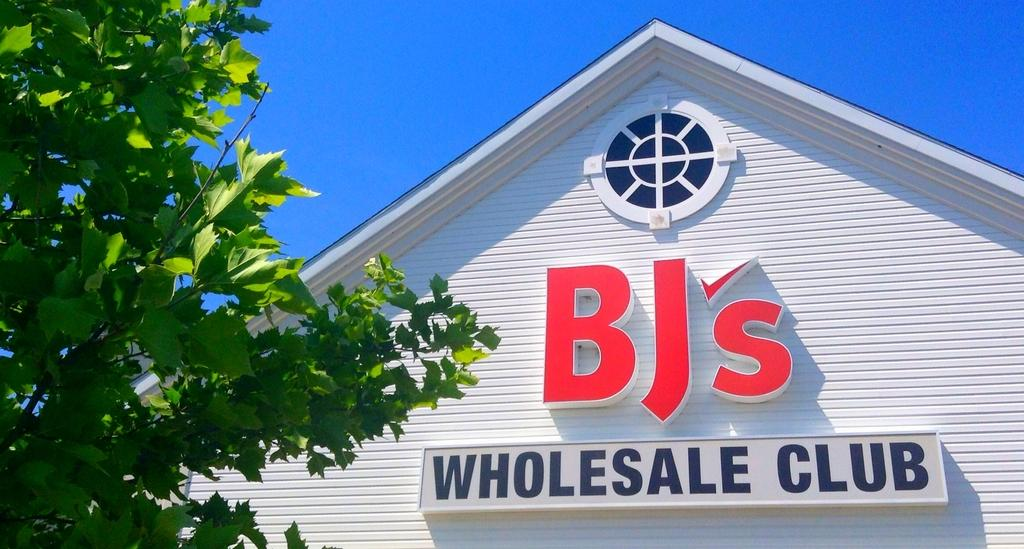Provide a one-sentence caption for the provided image. A tree is next to the side of a building which has a round window and lettering that reads BJ's Wholesale Club. 